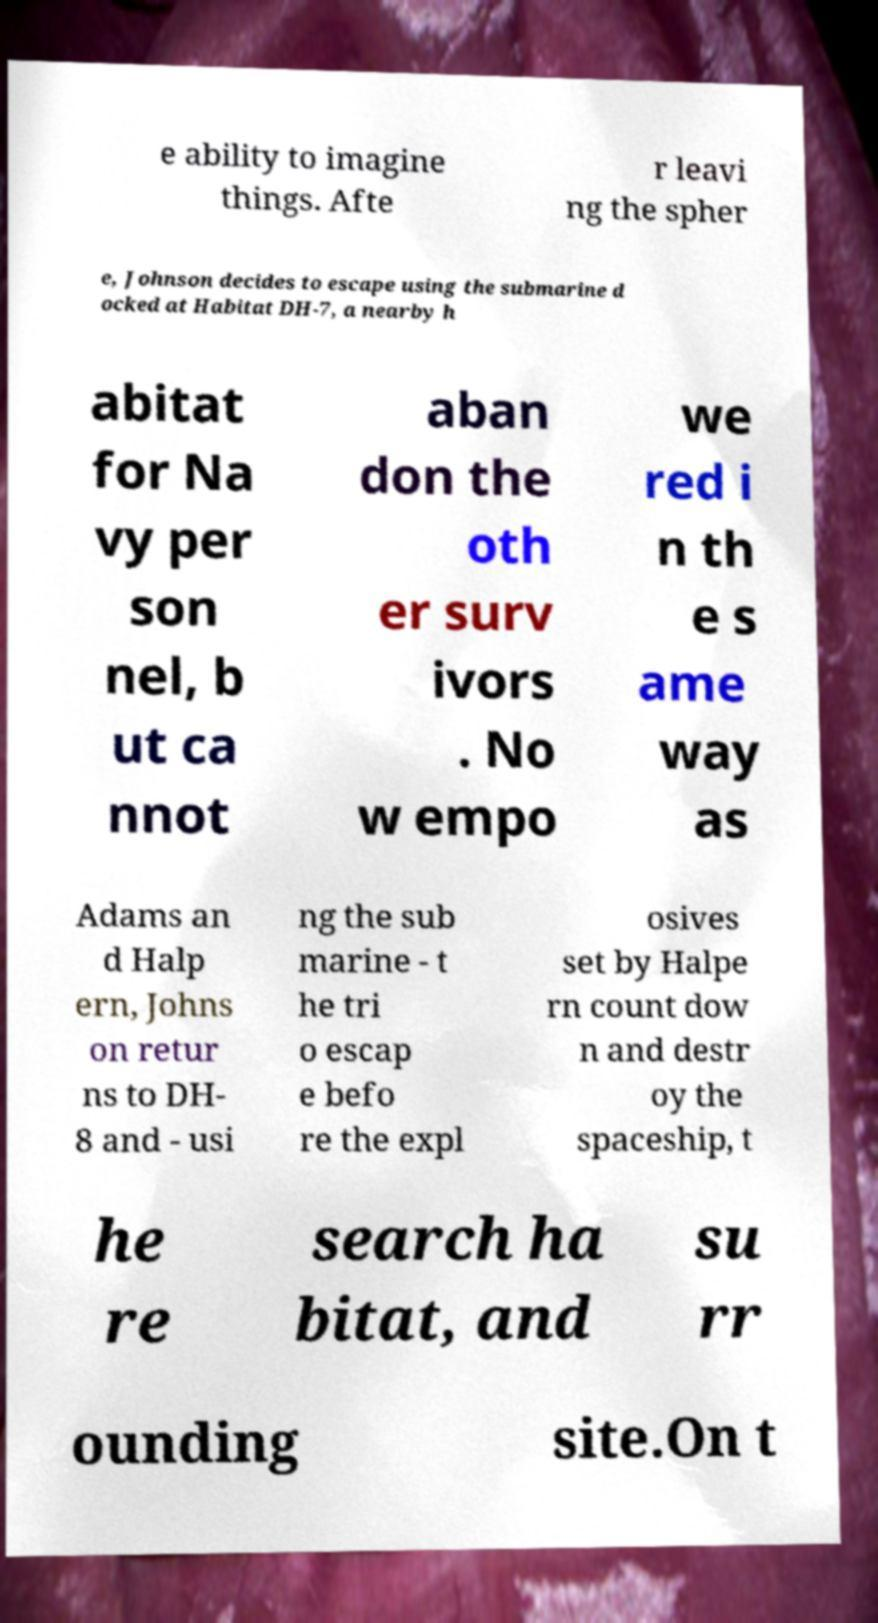For documentation purposes, I need the text within this image transcribed. Could you provide that? e ability to imagine things. Afte r leavi ng the spher e, Johnson decides to escape using the submarine d ocked at Habitat DH-7, a nearby h abitat for Na vy per son nel, b ut ca nnot aban don the oth er surv ivors . No w empo we red i n th e s ame way as Adams an d Halp ern, Johns on retur ns to DH- 8 and - usi ng the sub marine - t he tri o escap e befo re the expl osives set by Halpe rn count dow n and destr oy the spaceship, t he re search ha bitat, and su rr ounding site.On t 